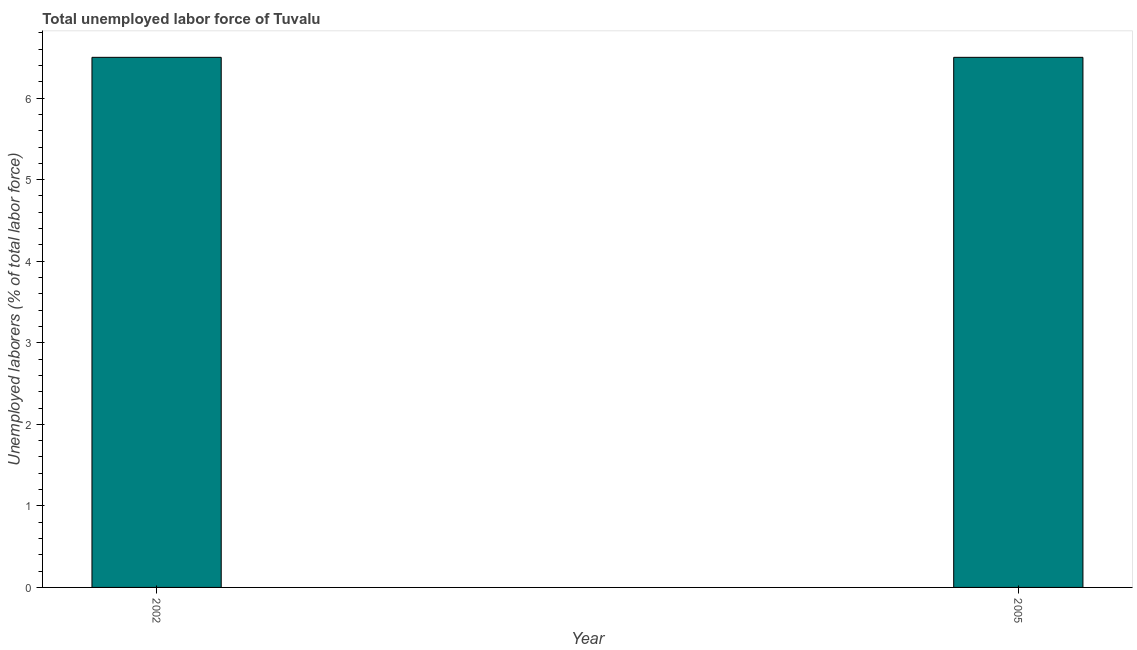Does the graph contain any zero values?
Offer a very short reply. No. What is the title of the graph?
Make the answer very short. Total unemployed labor force of Tuvalu. What is the label or title of the Y-axis?
Offer a terse response. Unemployed laborers (% of total labor force). What is the total unemployed labour force in 2005?
Make the answer very short. 6.5. In which year was the total unemployed labour force maximum?
Ensure brevity in your answer.  2002. In which year was the total unemployed labour force minimum?
Ensure brevity in your answer.  2002. What is the sum of the total unemployed labour force?
Give a very brief answer. 13. What is the average total unemployed labour force per year?
Offer a very short reply. 6.5. Do a majority of the years between 2002 and 2005 (inclusive) have total unemployed labour force greater than 5.8 %?
Offer a terse response. Yes. What is the ratio of the total unemployed labour force in 2002 to that in 2005?
Offer a very short reply. 1. In how many years, is the total unemployed labour force greater than the average total unemployed labour force taken over all years?
Your answer should be compact. 0. Are the values on the major ticks of Y-axis written in scientific E-notation?
Ensure brevity in your answer.  No. What is the Unemployed laborers (% of total labor force) in 2002?
Offer a terse response. 6.5. What is the Unemployed laborers (% of total labor force) of 2005?
Keep it short and to the point. 6.5. What is the difference between the Unemployed laborers (% of total labor force) in 2002 and 2005?
Ensure brevity in your answer.  0. 